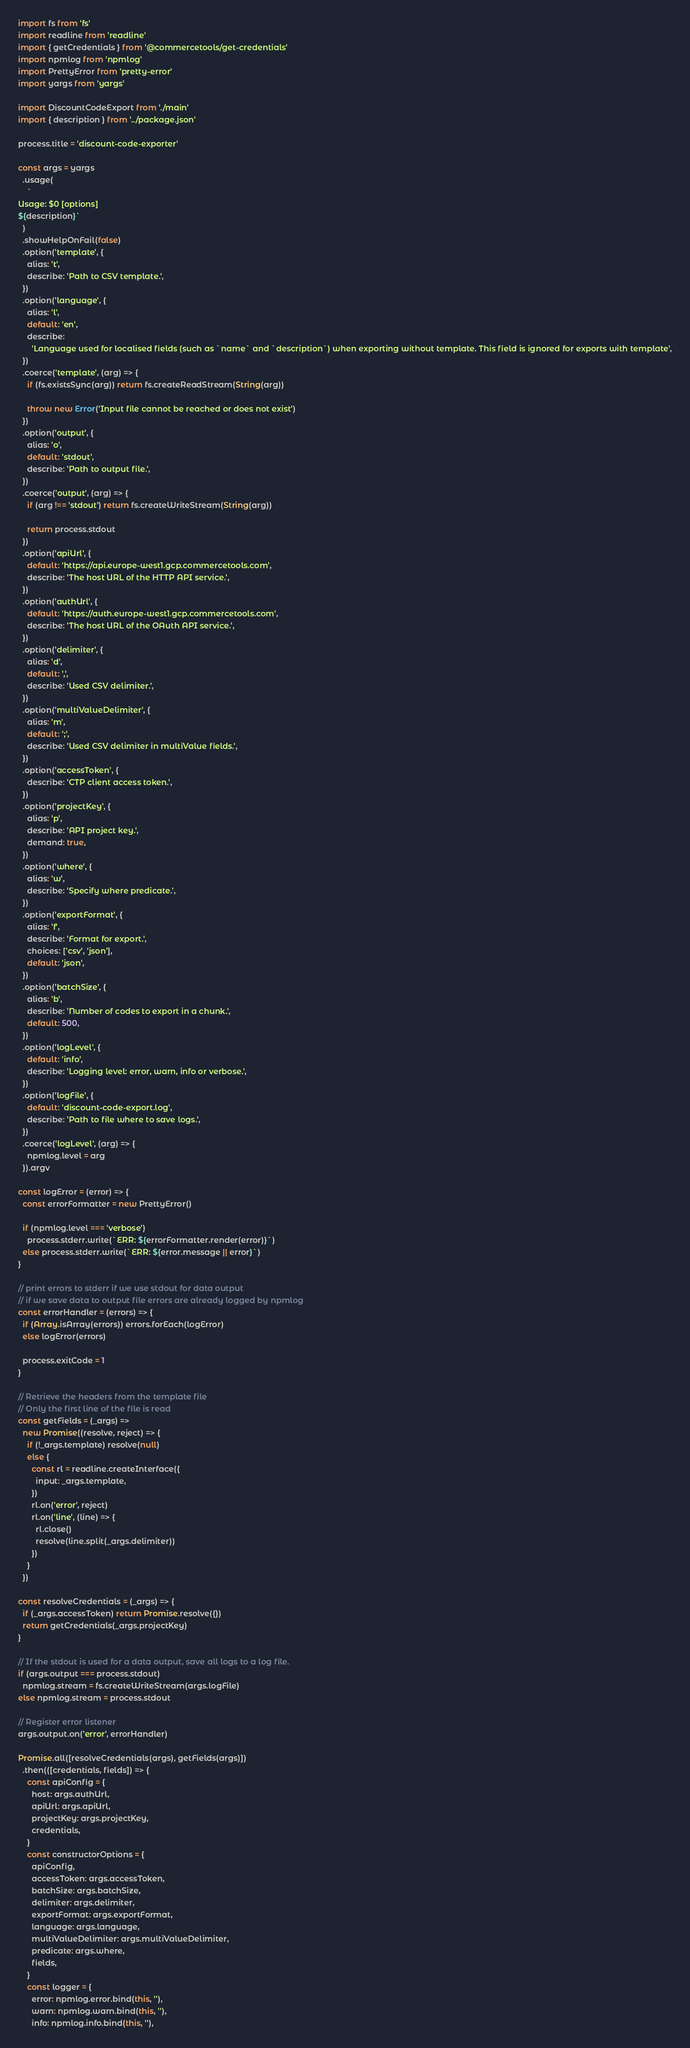Convert code to text. <code><loc_0><loc_0><loc_500><loc_500><_JavaScript_>import fs from 'fs'
import readline from 'readline'
import { getCredentials } from '@commercetools/get-credentials'
import npmlog from 'npmlog'
import PrettyError from 'pretty-error'
import yargs from 'yargs'

import DiscountCodeExport from './main'
import { description } from '../package.json'

process.title = 'discount-code-exporter'

const args = yargs
  .usage(
    `
Usage: $0 [options]
${description}`
  )
  .showHelpOnFail(false)
  .option('template', {
    alias: 't',
    describe: 'Path to CSV template.',
  })
  .option('language', {
    alias: 'l',
    default: 'en',
    describe:
      'Language used for localised fields (such as `name` and `description`) when exporting without template. This field is ignored for exports with template',
  })
  .coerce('template', (arg) => {
    if (fs.existsSync(arg)) return fs.createReadStream(String(arg))

    throw new Error('Input file cannot be reached or does not exist')
  })
  .option('output', {
    alias: 'o',
    default: 'stdout',
    describe: 'Path to output file.',
  })
  .coerce('output', (arg) => {
    if (arg !== 'stdout') return fs.createWriteStream(String(arg))

    return process.stdout
  })
  .option('apiUrl', {
    default: 'https://api.europe-west1.gcp.commercetools.com',
    describe: 'The host URL of the HTTP API service.',
  })
  .option('authUrl', {
    default: 'https://auth.europe-west1.gcp.commercetools.com',
    describe: 'The host URL of the OAuth API service.',
  })
  .option('delimiter', {
    alias: 'd',
    default: ',',
    describe: 'Used CSV delimiter.',
  })
  .option('multiValueDelimiter', {
    alias: 'm',
    default: ';',
    describe: 'Used CSV delimiter in multiValue fields.',
  })
  .option('accessToken', {
    describe: 'CTP client access token.',
  })
  .option('projectKey', {
    alias: 'p',
    describe: 'API project key.',
    demand: true,
  })
  .option('where', {
    alias: 'w',
    describe: 'Specify where predicate.',
  })
  .option('exportFormat', {
    alias: 'f',
    describe: 'Format for export.',
    choices: ['csv', 'json'],
    default: 'json',
  })
  .option('batchSize', {
    alias: 'b',
    describe: 'Number of codes to export in a chunk.',
    default: 500,
  })
  .option('logLevel', {
    default: 'info',
    describe: 'Logging level: error, warn, info or verbose.',
  })
  .option('logFile', {
    default: 'discount-code-export.log',
    describe: 'Path to file where to save logs.',
  })
  .coerce('logLevel', (arg) => {
    npmlog.level = arg
  }).argv

const logError = (error) => {
  const errorFormatter = new PrettyError()

  if (npmlog.level === 'verbose')
    process.stderr.write(`ERR: ${errorFormatter.render(error)}`)
  else process.stderr.write(`ERR: ${error.message || error}`)
}

// print errors to stderr if we use stdout for data output
// if we save data to output file errors are already logged by npmlog
const errorHandler = (errors) => {
  if (Array.isArray(errors)) errors.forEach(logError)
  else logError(errors)

  process.exitCode = 1
}

// Retrieve the headers from the template file
// Only the first line of the file is read
const getFields = (_args) =>
  new Promise((resolve, reject) => {
    if (!_args.template) resolve(null)
    else {
      const rl = readline.createInterface({
        input: _args.template,
      })
      rl.on('error', reject)
      rl.on('line', (line) => {
        rl.close()
        resolve(line.split(_args.delimiter))
      })
    }
  })

const resolveCredentials = (_args) => {
  if (_args.accessToken) return Promise.resolve({})
  return getCredentials(_args.projectKey)
}

// If the stdout is used for a data output, save all logs to a log file.
if (args.output === process.stdout)
  npmlog.stream = fs.createWriteStream(args.logFile)
else npmlog.stream = process.stdout

// Register error listener
args.output.on('error', errorHandler)

Promise.all([resolveCredentials(args), getFields(args)])
  .then(([credentials, fields]) => {
    const apiConfig = {
      host: args.authUrl,
      apiUrl: args.apiUrl,
      projectKey: args.projectKey,
      credentials,
    }
    const constructorOptions = {
      apiConfig,
      accessToken: args.accessToken,
      batchSize: args.batchSize,
      delimiter: args.delimiter,
      exportFormat: args.exportFormat,
      language: args.language,
      multiValueDelimiter: args.multiValueDelimiter,
      predicate: args.where,
      fields,
    }
    const logger = {
      error: npmlog.error.bind(this, ''),
      warn: npmlog.warn.bind(this, ''),
      info: npmlog.info.bind(this, ''),</code> 